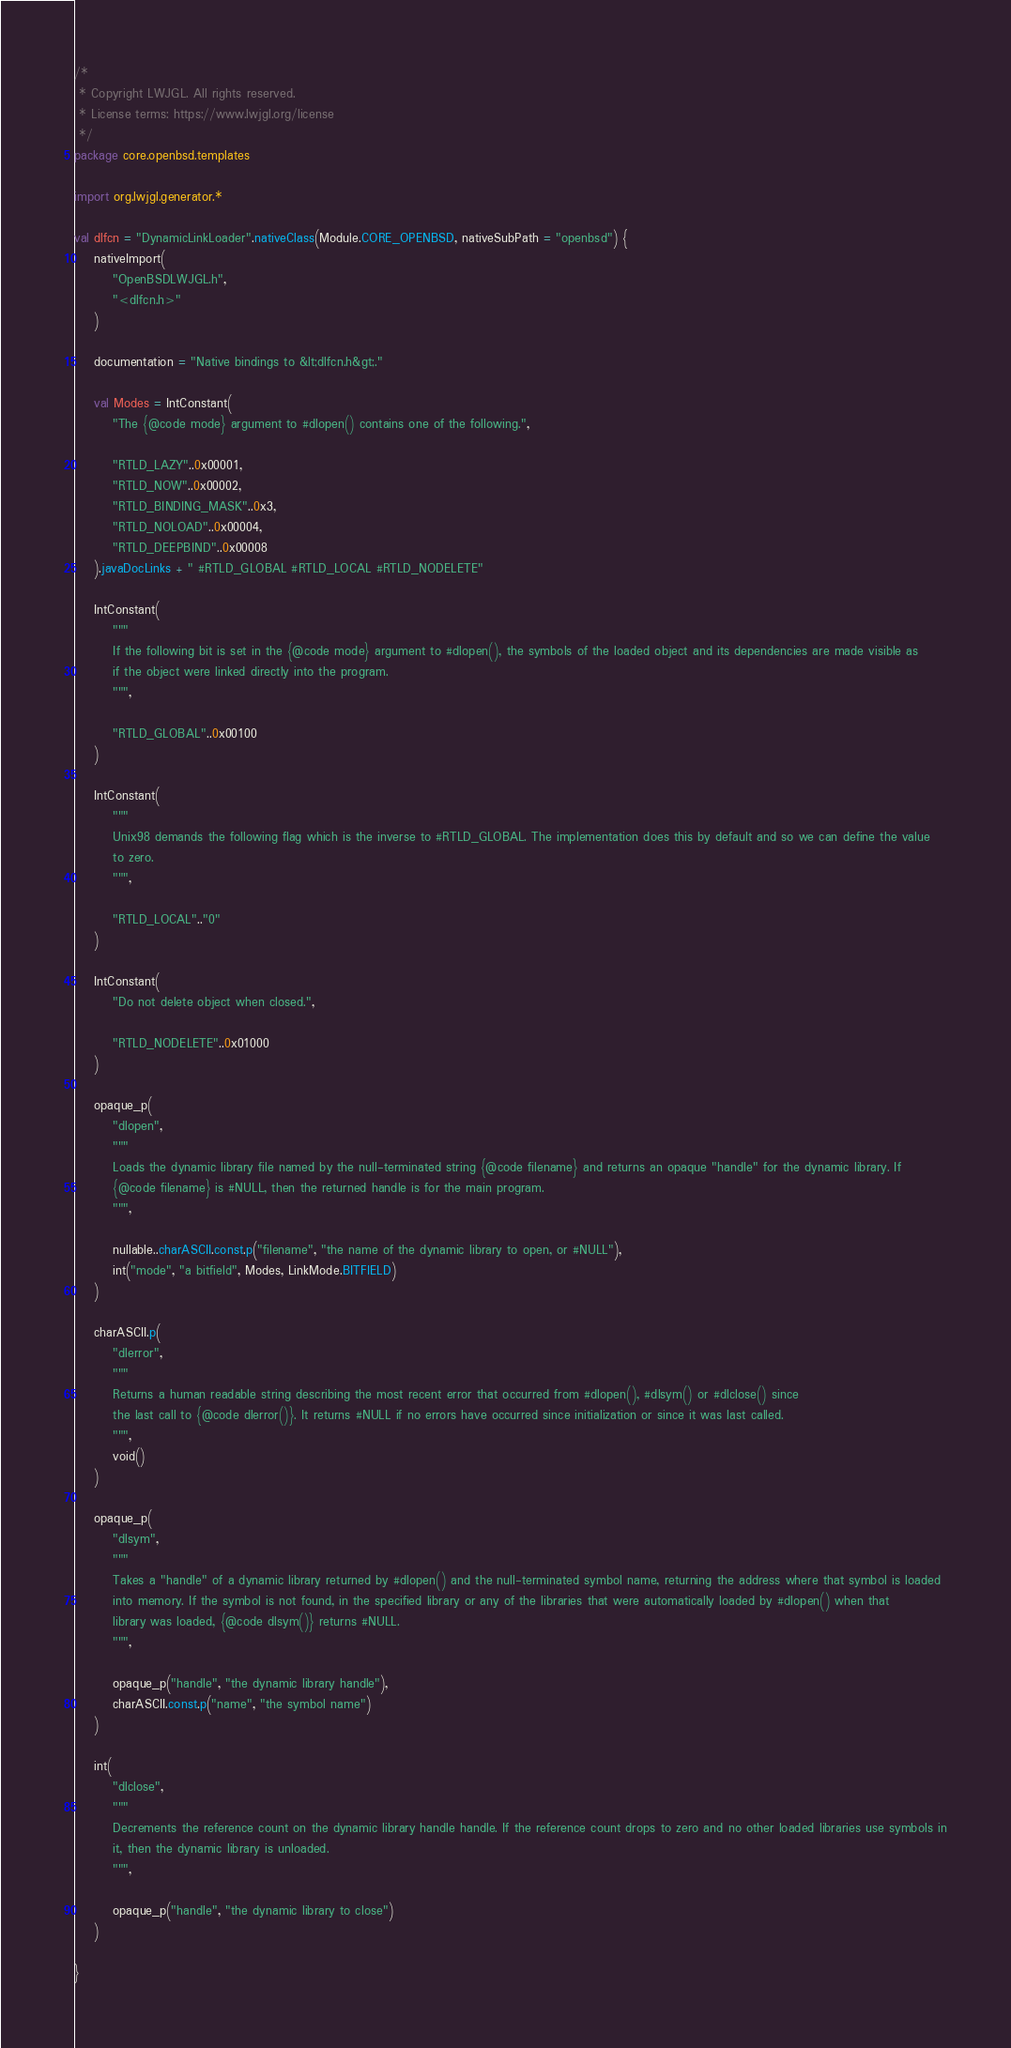<code> <loc_0><loc_0><loc_500><loc_500><_Kotlin_>/*
 * Copyright LWJGL. All rights reserved.
 * License terms: https://www.lwjgl.org/license
 */
package core.openbsd.templates

import org.lwjgl.generator.*

val dlfcn = "DynamicLinkLoader".nativeClass(Module.CORE_OPENBSD, nativeSubPath = "openbsd") {
    nativeImport(
        "OpenBSDLWJGL.h",
        "<dlfcn.h>"
    )

    documentation = "Native bindings to &lt;dlfcn.h&gt;."

    val Modes = IntConstant(
        "The {@code mode} argument to #dlopen() contains one of the following.",

        "RTLD_LAZY"..0x00001,
        "RTLD_NOW"..0x00002,
        "RTLD_BINDING_MASK"..0x3,
        "RTLD_NOLOAD"..0x00004,
        "RTLD_DEEPBIND"..0x00008
    ).javaDocLinks + " #RTLD_GLOBAL #RTLD_LOCAL #RTLD_NODELETE"

    IntConstant(
        """
        If the following bit is set in the {@code mode} argument to #dlopen(), the symbols of the loaded object and its dependencies are made visible as
        if the object were linked directly into the program.
        """,

        "RTLD_GLOBAL"..0x00100
    )

    IntConstant(
        """
        Unix98 demands the following flag which is the inverse to #RTLD_GLOBAL. The implementation does this by default and so we can define the value
        to zero.
        """,

        "RTLD_LOCAL".."0"
    )

    IntConstant(
        "Do not delete object when closed.",

        "RTLD_NODELETE"..0x01000
    )

    opaque_p(
        "dlopen",
        """
        Loads the dynamic library file named by the null-terminated string {@code filename} and returns an opaque "handle" for the dynamic library. If
        {@code filename} is #NULL, then the returned handle is for the main program.
        """,

        nullable..charASCII.const.p("filename", "the name of the dynamic library to open, or #NULL"),
        int("mode", "a bitfield", Modes, LinkMode.BITFIELD)
    )

    charASCII.p(
        "dlerror",
        """
        Returns a human readable string describing the most recent error that occurred from #dlopen(), #dlsym() or #dlclose() since
        the last call to {@code dlerror()}. It returns #NULL if no errors have occurred since initialization or since it was last called.
        """,
        void()
    )

    opaque_p(
        "dlsym",
        """
        Takes a "handle" of a dynamic library returned by #dlopen() and the null-terminated symbol name, returning the address where that symbol is loaded
        into memory. If the symbol is not found, in the specified library or any of the libraries that were automatically loaded by #dlopen() when that
        library was loaded, {@code dlsym()} returns #NULL.
        """,

        opaque_p("handle", "the dynamic library handle"),
        charASCII.const.p("name", "the symbol name")
    )

    int(
        "dlclose",
        """
        Decrements the reference count on the dynamic library handle handle. If the reference count drops to zero and no other loaded libraries use symbols in
        it, then the dynamic library is unloaded.
        """,

        opaque_p("handle", "the dynamic library to close")
    )

}
</code> 